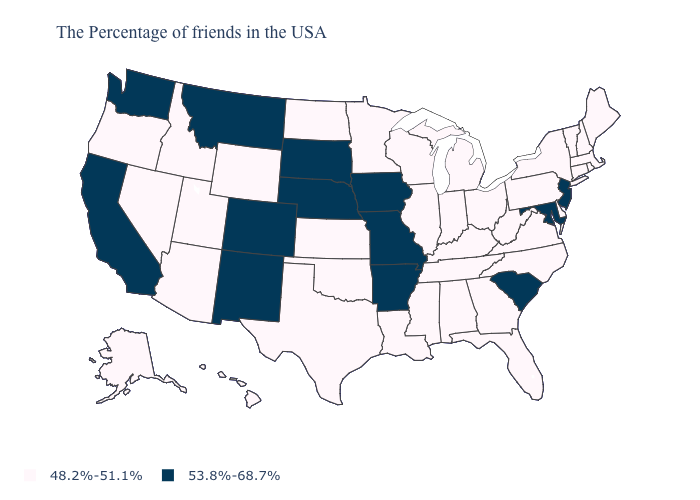Name the states that have a value in the range 48.2%-51.1%?
Write a very short answer. Maine, Massachusetts, Rhode Island, New Hampshire, Vermont, Connecticut, New York, Delaware, Pennsylvania, Virginia, North Carolina, West Virginia, Ohio, Florida, Georgia, Michigan, Kentucky, Indiana, Alabama, Tennessee, Wisconsin, Illinois, Mississippi, Louisiana, Minnesota, Kansas, Oklahoma, Texas, North Dakota, Wyoming, Utah, Arizona, Idaho, Nevada, Oregon, Alaska, Hawaii. What is the lowest value in the USA?
Answer briefly. 48.2%-51.1%. What is the value of Wyoming?
Short answer required. 48.2%-51.1%. Does South Dakota have a higher value than Georgia?
Quick response, please. Yes. Which states have the lowest value in the USA?
Keep it brief. Maine, Massachusetts, Rhode Island, New Hampshire, Vermont, Connecticut, New York, Delaware, Pennsylvania, Virginia, North Carolina, West Virginia, Ohio, Florida, Georgia, Michigan, Kentucky, Indiana, Alabama, Tennessee, Wisconsin, Illinois, Mississippi, Louisiana, Minnesota, Kansas, Oklahoma, Texas, North Dakota, Wyoming, Utah, Arizona, Idaho, Nevada, Oregon, Alaska, Hawaii. What is the value of Connecticut?
Give a very brief answer. 48.2%-51.1%. Among the states that border Arizona , does New Mexico have the highest value?
Be succinct. Yes. What is the value of Oklahoma?
Concise answer only. 48.2%-51.1%. Name the states that have a value in the range 48.2%-51.1%?
Give a very brief answer. Maine, Massachusetts, Rhode Island, New Hampshire, Vermont, Connecticut, New York, Delaware, Pennsylvania, Virginia, North Carolina, West Virginia, Ohio, Florida, Georgia, Michigan, Kentucky, Indiana, Alabama, Tennessee, Wisconsin, Illinois, Mississippi, Louisiana, Minnesota, Kansas, Oklahoma, Texas, North Dakota, Wyoming, Utah, Arizona, Idaho, Nevada, Oregon, Alaska, Hawaii. What is the value of Mississippi?
Quick response, please. 48.2%-51.1%. What is the value of Nevada?
Give a very brief answer. 48.2%-51.1%. What is the lowest value in the USA?
Answer briefly. 48.2%-51.1%. Name the states that have a value in the range 53.8%-68.7%?
Write a very short answer. New Jersey, Maryland, South Carolina, Missouri, Arkansas, Iowa, Nebraska, South Dakota, Colorado, New Mexico, Montana, California, Washington. What is the value of Nevada?
Give a very brief answer. 48.2%-51.1%. Does New Hampshire have the lowest value in the USA?
Give a very brief answer. Yes. 